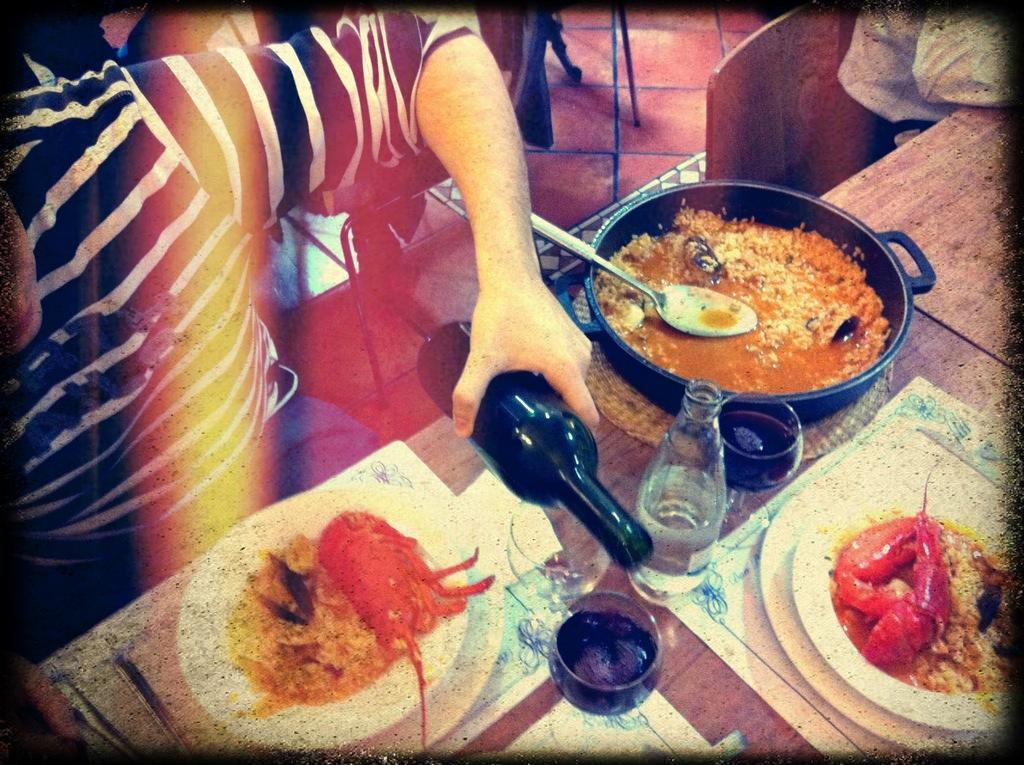What is the person in the image doing? The person is sitting in the image. What is the person holding? The person is holding a bottle. What can be seen on the table in the image? There is a plate, a bowl, a spoon, food, a bottle, and a glass on the table. How many chairs are visible in the image? There are chairs in the image. How many chickens are present in the image? There are no chickens present in the image. What is the person's desire for the food on the table? The image does not provide information about the person's desires or intentions regarding the food. 